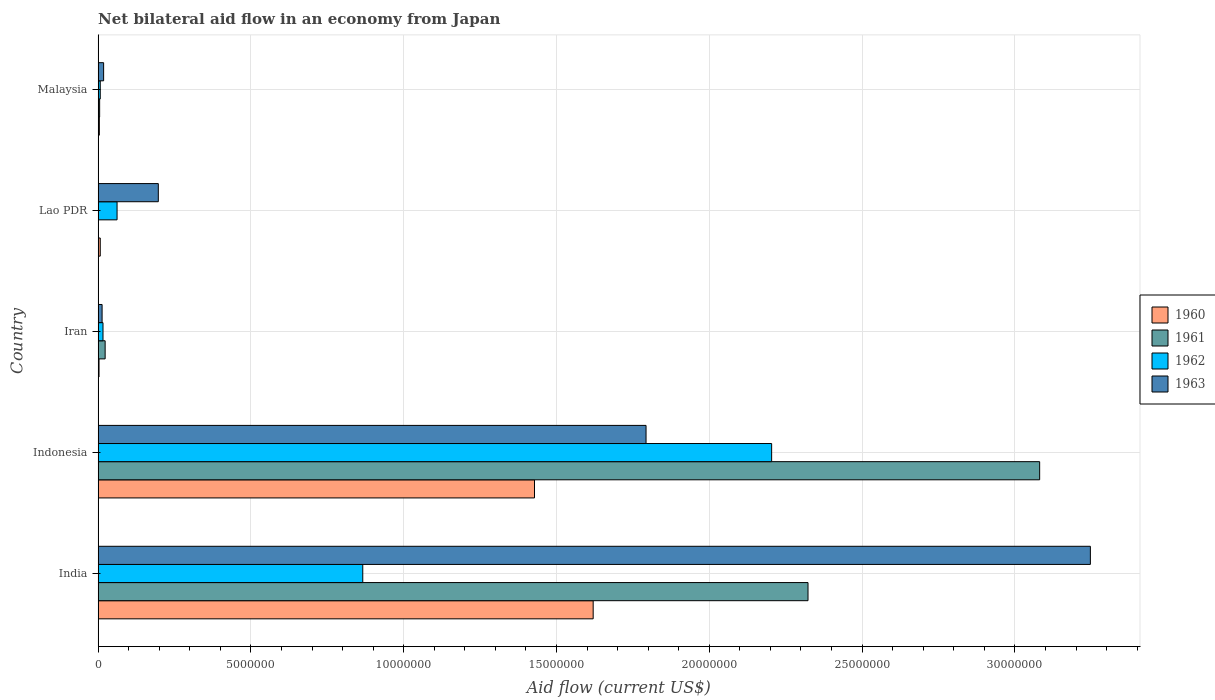Are the number of bars per tick equal to the number of legend labels?
Your answer should be very brief. Yes. How many bars are there on the 2nd tick from the top?
Your answer should be compact. 4. What is the net bilateral aid flow in 1960 in Indonesia?
Your answer should be very brief. 1.43e+07. Across all countries, what is the maximum net bilateral aid flow in 1962?
Provide a short and direct response. 2.20e+07. In which country was the net bilateral aid flow in 1962 minimum?
Keep it short and to the point. Malaysia. What is the total net bilateral aid flow in 1963 in the graph?
Your answer should be very brief. 5.27e+07. What is the difference between the net bilateral aid flow in 1961 in India and that in Iran?
Provide a succinct answer. 2.30e+07. What is the difference between the net bilateral aid flow in 1960 in Malaysia and the net bilateral aid flow in 1963 in Indonesia?
Offer a terse response. -1.79e+07. What is the average net bilateral aid flow in 1963 per country?
Make the answer very short. 1.05e+07. What is the difference between the net bilateral aid flow in 1961 and net bilateral aid flow in 1963 in Indonesia?
Offer a very short reply. 1.29e+07. What is the ratio of the net bilateral aid flow in 1962 in Indonesia to that in Iran?
Provide a short and direct response. 137.75. Is the net bilateral aid flow in 1963 in Lao PDR less than that in Malaysia?
Offer a very short reply. No. What is the difference between the highest and the second highest net bilateral aid flow in 1963?
Offer a terse response. 1.45e+07. What is the difference between the highest and the lowest net bilateral aid flow in 1960?
Your response must be concise. 1.62e+07. What does the 1st bar from the bottom in Malaysia represents?
Your answer should be very brief. 1960. Is it the case that in every country, the sum of the net bilateral aid flow in 1963 and net bilateral aid flow in 1962 is greater than the net bilateral aid flow in 1960?
Offer a terse response. Yes. Are all the bars in the graph horizontal?
Offer a very short reply. Yes. What is the difference between two consecutive major ticks on the X-axis?
Provide a succinct answer. 5.00e+06. Are the values on the major ticks of X-axis written in scientific E-notation?
Ensure brevity in your answer.  No. Does the graph contain any zero values?
Offer a terse response. No. Does the graph contain grids?
Make the answer very short. Yes. How many legend labels are there?
Your response must be concise. 4. What is the title of the graph?
Your response must be concise. Net bilateral aid flow in an economy from Japan. Does "1964" appear as one of the legend labels in the graph?
Provide a succinct answer. No. What is the label or title of the Y-axis?
Give a very brief answer. Country. What is the Aid flow (current US$) in 1960 in India?
Provide a short and direct response. 1.62e+07. What is the Aid flow (current US$) in 1961 in India?
Your answer should be very brief. 2.32e+07. What is the Aid flow (current US$) of 1962 in India?
Give a very brief answer. 8.66e+06. What is the Aid flow (current US$) of 1963 in India?
Offer a very short reply. 3.25e+07. What is the Aid flow (current US$) of 1960 in Indonesia?
Offer a terse response. 1.43e+07. What is the Aid flow (current US$) in 1961 in Indonesia?
Provide a short and direct response. 3.08e+07. What is the Aid flow (current US$) in 1962 in Indonesia?
Ensure brevity in your answer.  2.20e+07. What is the Aid flow (current US$) in 1963 in Indonesia?
Your response must be concise. 1.79e+07. What is the Aid flow (current US$) in 1960 in Iran?
Make the answer very short. 3.00e+04. What is the Aid flow (current US$) of 1961 in Iran?
Provide a succinct answer. 2.30e+05. What is the Aid flow (current US$) in 1962 in Iran?
Your answer should be very brief. 1.60e+05. What is the Aid flow (current US$) of 1961 in Lao PDR?
Offer a very short reply. 10000. What is the Aid flow (current US$) in 1962 in Lao PDR?
Make the answer very short. 6.20e+05. What is the Aid flow (current US$) of 1963 in Lao PDR?
Your response must be concise. 1.97e+06. What is the Aid flow (current US$) in 1961 in Malaysia?
Your response must be concise. 5.00e+04. Across all countries, what is the maximum Aid flow (current US$) in 1960?
Provide a succinct answer. 1.62e+07. Across all countries, what is the maximum Aid flow (current US$) of 1961?
Your answer should be very brief. 3.08e+07. Across all countries, what is the maximum Aid flow (current US$) in 1962?
Provide a succinct answer. 2.20e+07. Across all countries, what is the maximum Aid flow (current US$) of 1963?
Provide a succinct answer. 3.25e+07. Across all countries, what is the minimum Aid flow (current US$) in 1963?
Your answer should be very brief. 1.30e+05. What is the total Aid flow (current US$) of 1960 in the graph?
Give a very brief answer. 3.06e+07. What is the total Aid flow (current US$) of 1961 in the graph?
Ensure brevity in your answer.  5.43e+07. What is the total Aid flow (current US$) of 1962 in the graph?
Your response must be concise. 3.16e+07. What is the total Aid flow (current US$) in 1963 in the graph?
Make the answer very short. 5.27e+07. What is the difference between the Aid flow (current US$) of 1960 in India and that in Indonesia?
Provide a short and direct response. 1.92e+06. What is the difference between the Aid flow (current US$) of 1961 in India and that in Indonesia?
Make the answer very short. -7.58e+06. What is the difference between the Aid flow (current US$) of 1962 in India and that in Indonesia?
Offer a terse response. -1.34e+07. What is the difference between the Aid flow (current US$) in 1963 in India and that in Indonesia?
Your response must be concise. 1.45e+07. What is the difference between the Aid flow (current US$) of 1960 in India and that in Iran?
Make the answer very short. 1.62e+07. What is the difference between the Aid flow (current US$) of 1961 in India and that in Iran?
Ensure brevity in your answer.  2.30e+07. What is the difference between the Aid flow (current US$) of 1962 in India and that in Iran?
Keep it short and to the point. 8.50e+06. What is the difference between the Aid flow (current US$) in 1963 in India and that in Iran?
Give a very brief answer. 3.23e+07. What is the difference between the Aid flow (current US$) in 1960 in India and that in Lao PDR?
Provide a succinct answer. 1.61e+07. What is the difference between the Aid flow (current US$) of 1961 in India and that in Lao PDR?
Give a very brief answer. 2.32e+07. What is the difference between the Aid flow (current US$) in 1962 in India and that in Lao PDR?
Your answer should be compact. 8.04e+06. What is the difference between the Aid flow (current US$) in 1963 in India and that in Lao PDR?
Keep it short and to the point. 3.05e+07. What is the difference between the Aid flow (current US$) in 1960 in India and that in Malaysia?
Your answer should be compact. 1.62e+07. What is the difference between the Aid flow (current US$) in 1961 in India and that in Malaysia?
Provide a succinct answer. 2.32e+07. What is the difference between the Aid flow (current US$) of 1962 in India and that in Malaysia?
Keep it short and to the point. 8.59e+06. What is the difference between the Aid flow (current US$) in 1963 in India and that in Malaysia?
Your answer should be compact. 3.23e+07. What is the difference between the Aid flow (current US$) in 1960 in Indonesia and that in Iran?
Provide a short and direct response. 1.42e+07. What is the difference between the Aid flow (current US$) in 1961 in Indonesia and that in Iran?
Ensure brevity in your answer.  3.06e+07. What is the difference between the Aid flow (current US$) in 1962 in Indonesia and that in Iran?
Offer a very short reply. 2.19e+07. What is the difference between the Aid flow (current US$) of 1963 in Indonesia and that in Iran?
Keep it short and to the point. 1.78e+07. What is the difference between the Aid flow (current US$) of 1960 in Indonesia and that in Lao PDR?
Make the answer very short. 1.42e+07. What is the difference between the Aid flow (current US$) in 1961 in Indonesia and that in Lao PDR?
Keep it short and to the point. 3.08e+07. What is the difference between the Aid flow (current US$) of 1962 in Indonesia and that in Lao PDR?
Give a very brief answer. 2.14e+07. What is the difference between the Aid flow (current US$) in 1963 in Indonesia and that in Lao PDR?
Provide a succinct answer. 1.60e+07. What is the difference between the Aid flow (current US$) in 1960 in Indonesia and that in Malaysia?
Keep it short and to the point. 1.42e+07. What is the difference between the Aid flow (current US$) in 1961 in Indonesia and that in Malaysia?
Provide a succinct answer. 3.08e+07. What is the difference between the Aid flow (current US$) of 1962 in Indonesia and that in Malaysia?
Provide a succinct answer. 2.20e+07. What is the difference between the Aid flow (current US$) in 1963 in Indonesia and that in Malaysia?
Give a very brief answer. 1.78e+07. What is the difference between the Aid flow (current US$) of 1960 in Iran and that in Lao PDR?
Keep it short and to the point. -4.00e+04. What is the difference between the Aid flow (current US$) of 1962 in Iran and that in Lao PDR?
Your answer should be compact. -4.60e+05. What is the difference between the Aid flow (current US$) of 1963 in Iran and that in Lao PDR?
Your answer should be compact. -1.84e+06. What is the difference between the Aid flow (current US$) of 1961 in Iran and that in Malaysia?
Keep it short and to the point. 1.80e+05. What is the difference between the Aid flow (current US$) in 1963 in Iran and that in Malaysia?
Provide a succinct answer. -5.00e+04. What is the difference between the Aid flow (current US$) of 1961 in Lao PDR and that in Malaysia?
Your response must be concise. -4.00e+04. What is the difference between the Aid flow (current US$) of 1963 in Lao PDR and that in Malaysia?
Make the answer very short. 1.79e+06. What is the difference between the Aid flow (current US$) of 1960 in India and the Aid flow (current US$) of 1961 in Indonesia?
Your answer should be compact. -1.46e+07. What is the difference between the Aid flow (current US$) in 1960 in India and the Aid flow (current US$) in 1962 in Indonesia?
Keep it short and to the point. -5.84e+06. What is the difference between the Aid flow (current US$) in 1960 in India and the Aid flow (current US$) in 1963 in Indonesia?
Make the answer very short. -1.73e+06. What is the difference between the Aid flow (current US$) in 1961 in India and the Aid flow (current US$) in 1962 in Indonesia?
Give a very brief answer. 1.19e+06. What is the difference between the Aid flow (current US$) of 1961 in India and the Aid flow (current US$) of 1963 in Indonesia?
Your answer should be very brief. 5.30e+06. What is the difference between the Aid flow (current US$) in 1962 in India and the Aid flow (current US$) in 1963 in Indonesia?
Provide a succinct answer. -9.27e+06. What is the difference between the Aid flow (current US$) in 1960 in India and the Aid flow (current US$) in 1961 in Iran?
Provide a short and direct response. 1.60e+07. What is the difference between the Aid flow (current US$) in 1960 in India and the Aid flow (current US$) in 1962 in Iran?
Make the answer very short. 1.60e+07. What is the difference between the Aid flow (current US$) in 1960 in India and the Aid flow (current US$) in 1963 in Iran?
Your answer should be very brief. 1.61e+07. What is the difference between the Aid flow (current US$) in 1961 in India and the Aid flow (current US$) in 1962 in Iran?
Offer a terse response. 2.31e+07. What is the difference between the Aid flow (current US$) of 1961 in India and the Aid flow (current US$) of 1963 in Iran?
Offer a terse response. 2.31e+07. What is the difference between the Aid flow (current US$) of 1962 in India and the Aid flow (current US$) of 1963 in Iran?
Your answer should be compact. 8.53e+06. What is the difference between the Aid flow (current US$) of 1960 in India and the Aid flow (current US$) of 1961 in Lao PDR?
Provide a succinct answer. 1.62e+07. What is the difference between the Aid flow (current US$) of 1960 in India and the Aid flow (current US$) of 1962 in Lao PDR?
Offer a very short reply. 1.56e+07. What is the difference between the Aid flow (current US$) in 1960 in India and the Aid flow (current US$) in 1963 in Lao PDR?
Make the answer very short. 1.42e+07. What is the difference between the Aid flow (current US$) of 1961 in India and the Aid flow (current US$) of 1962 in Lao PDR?
Keep it short and to the point. 2.26e+07. What is the difference between the Aid flow (current US$) in 1961 in India and the Aid flow (current US$) in 1963 in Lao PDR?
Make the answer very short. 2.13e+07. What is the difference between the Aid flow (current US$) in 1962 in India and the Aid flow (current US$) in 1963 in Lao PDR?
Provide a short and direct response. 6.69e+06. What is the difference between the Aid flow (current US$) of 1960 in India and the Aid flow (current US$) of 1961 in Malaysia?
Your response must be concise. 1.62e+07. What is the difference between the Aid flow (current US$) in 1960 in India and the Aid flow (current US$) in 1962 in Malaysia?
Provide a short and direct response. 1.61e+07. What is the difference between the Aid flow (current US$) of 1960 in India and the Aid flow (current US$) of 1963 in Malaysia?
Your answer should be compact. 1.60e+07. What is the difference between the Aid flow (current US$) of 1961 in India and the Aid flow (current US$) of 1962 in Malaysia?
Your response must be concise. 2.32e+07. What is the difference between the Aid flow (current US$) in 1961 in India and the Aid flow (current US$) in 1963 in Malaysia?
Your answer should be compact. 2.30e+07. What is the difference between the Aid flow (current US$) of 1962 in India and the Aid flow (current US$) of 1963 in Malaysia?
Keep it short and to the point. 8.48e+06. What is the difference between the Aid flow (current US$) of 1960 in Indonesia and the Aid flow (current US$) of 1961 in Iran?
Your answer should be compact. 1.40e+07. What is the difference between the Aid flow (current US$) of 1960 in Indonesia and the Aid flow (current US$) of 1962 in Iran?
Make the answer very short. 1.41e+07. What is the difference between the Aid flow (current US$) in 1960 in Indonesia and the Aid flow (current US$) in 1963 in Iran?
Give a very brief answer. 1.42e+07. What is the difference between the Aid flow (current US$) of 1961 in Indonesia and the Aid flow (current US$) of 1962 in Iran?
Keep it short and to the point. 3.06e+07. What is the difference between the Aid flow (current US$) of 1961 in Indonesia and the Aid flow (current US$) of 1963 in Iran?
Offer a very short reply. 3.07e+07. What is the difference between the Aid flow (current US$) of 1962 in Indonesia and the Aid flow (current US$) of 1963 in Iran?
Keep it short and to the point. 2.19e+07. What is the difference between the Aid flow (current US$) in 1960 in Indonesia and the Aid flow (current US$) in 1961 in Lao PDR?
Your response must be concise. 1.43e+07. What is the difference between the Aid flow (current US$) of 1960 in Indonesia and the Aid flow (current US$) of 1962 in Lao PDR?
Your response must be concise. 1.37e+07. What is the difference between the Aid flow (current US$) of 1960 in Indonesia and the Aid flow (current US$) of 1963 in Lao PDR?
Keep it short and to the point. 1.23e+07. What is the difference between the Aid flow (current US$) of 1961 in Indonesia and the Aid flow (current US$) of 1962 in Lao PDR?
Make the answer very short. 3.02e+07. What is the difference between the Aid flow (current US$) in 1961 in Indonesia and the Aid flow (current US$) in 1963 in Lao PDR?
Your answer should be very brief. 2.88e+07. What is the difference between the Aid flow (current US$) of 1962 in Indonesia and the Aid flow (current US$) of 1963 in Lao PDR?
Give a very brief answer. 2.01e+07. What is the difference between the Aid flow (current US$) in 1960 in Indonesia and the Aid flow (current US$) in 1961 in Malaysia?
Provide a short and direct response. 1.42e+07. What is the difference between the Aid flow (current US$) in 1960 in Indonesia and the Aid flow (current US$) in 1962 in Malaysia?
Provide a short and direct response. 1.42e+07. What is the difference between the Aid flow (current US$) of 1960 in Indonesia and the Aid flow (current US$) of 1963 in Malaysia?
Give a very brief answer. 1.41e+07. What is the difference between the Aid flow (current US$) in 1961 in Indonesia and the Aid flow (current US$) in 1962 in Malaysia?
Offer a terse response. 3.07e+07. What is the difference between the Aid flow (current US$) of 1961 in Indonesia and the Aid flow (current US$) of 1963 in Malaysia?
Give a very brief answer. 3.06e+07. What is the difference between the Aid flow (current US$) of 1962 in Indonesia and the Aid flow (current US$) of 1963 in Malaysia?
Offer a very short reply. 2.19e+07. What is the difference between the Aid flow (current US$) of 1960 in Iran and the Aid flow (current US$) of 1962 in Lao PDR?
Ensure brevity in your answer.  -5.90e+05. What is the difference between the Aid flow (current US$) in 1960 in Iran and the Aid flow (current US$) in 1963 in Lao PDR?
Your response must be concise. -1.94e+06. What is the difference between the Aid flow (current US$) in 1961 in Iran and the Aid flow (current US$) in 1962 in Lao PDR?
Make the answer very short. -3.90e+05. What is the difference between the Aid flow (current US$) in 1961 in Iran and the Aid flow (current US$) in 1963 in Lao PDR?
Provide a succinct answer. -1.74e+06. What is the difference between the Aid flow (current US$) in 1962 in Iran and the Aid flow (current US$) in 1963 in Lao PDR?
Provide a short and direct response. -1.81e+06. What is the difference between the Aid flow (current US$) in 1960 in Iran and the Aid flow (current US$) in 1962 in Malaysia?
Provide a succinct answer. -4.00e+04. What is the difference between the Aid flow (current US$) of 1961 in Iran and the Aid flow (current US$) of 1963 in Malaysia?
Ensure brevity in your answer.  5.00e+04. What is the difference between the Aid flow (current US$) of 1962 in Iran and the Aid flow (current US$) of 1963 in Malaysia?
Offer a very short reply. -2.00e+04. What is the difference between the Aid flow (current US$) in 1961 in Lao PDR and the Aid flow (current US$) in 1963 in Malaysia?
Your response must be concise. -1.70e+05. What is the average Aid flow (current US$) of 1960 per country?
Provide a succinct answer. 6.12e+06. What is the average Aid flow (current US$) of 1961 per country?
Ensure brevity in your answer.  1.09e+07. What is the average Aid flow (current US$) of 1962 per country?
Ensure brevity in your answer.  6.31e+06. What is the average Aid flow (current US$) of 1963 per country?
Keep it short and to the point. 1.05e+07. What is the difference between the Aid flow (current US$) in 1960 and Aid flow (current US$) in 1961 in India?
Offer a very short reply. -7.03e+06. What is the difference between the Aid flow (current US$) in 1960 and Aid flow (current US$) in 1962 in India?
Ensure brevity in your answer.  7.54e+06. What is the difference between the Aid flow (current US$) of 1960 and Aid flow (current US$) of 1963 in India?
Provide a short and direct response. -1.63e+07. What is the difference between the Aid flow (current US$) in 1961 and Aid flow (current US$) in 1962 in India?
Ensure brevity in your answer.  1.46e+07. What is the difference between the Aid flow (current US$) of 1961 and Aid flow (current US$) of 1963 in India?
Make the answer very short. -9.24e+06. What is the difference between the Aid flow (current US$) of 1962 and Aid flow (current US$) of 1963 in India?
Ensure brevity in your answer.  -2.38e+07. What is the difference between the Aid flow (current US$) of 1960 and Aid flow (current US$) of 1961 in Indonesia?
Your answer should be compact. -1.65e+07. What is the difference between the Aid flow (current US$) of 1960 and Aid flow (current US$) of 1962 in Indonesia?
Your answer should be very brief. -7.76e+06. What is the difference between the Aid flow (current US$) in 1960 and Aid flow (current US$) in 1963 in Indonesia?
Your answer should be very brief. -3.65e+06. What is the difference between the Aid flow (current US$) of 1961 and Aid flow (current US$) of 1962 in Indonesia?
Your answer should be compact. 8.77e+06. What is the difference between the Aid flow (current US$) in 1961 and Aid flow (current US$) in 1963 in Indonesia?
Make the answer very short. 1.29e+07. What is the difference between the Aid flow (current US$) of 1962 and Aid flow (current US$) of 1963 in Indonesia?
Make the answer very short. 4.11e+06. What is the difference between the Aid flow (current US$) in 1960 and Aid flow (current US$) in 1961 in Iran?
Provide a short and direct response. -2.00e+05. What is the difference between the Aid flow (current US$) of 1960 and Aid flow (current US$) of 1962 in Iran?
Your answer should be very brief. -1.30e+05. What is the difference between the Aid flow (current US$) in 1961 and Aid flow (current US$) in 1963 in Iran?
Your response must be concise. 1.00e+05. What is the difference between the Aid flow (current US$) in 1962 and Aid flow (current US$) in 1963 in Iran?
Provide a succinct answer. 3.00e+04. What is the difference between the Aid flow (current US$) of 1960 and Aid flow (current US$) of 1961 in Lao PDR?
Offer a very short reply. 6.00e+04. What is the difference between the Aid flow (current US$) of 1960 and Aid flow (current US$) of 1962 in Lao PDR?
Ensure brevity in your answer.  -5.50e+05. What is the difference between the Aid flow (current US$) of 1960 and Aid flow (current US$) of 1963 in Lao PDR?
Ensure brevity in your answer.  -1.90e+06. What is the difference between the Aid flow (current US$) in 1961 and Aid flow (current US$) in 1962 in Lao PDR?
Give a very brief answer. -6.10e+05. What is the difference between the Aid flow (current US$) in 1961 and Aid flow (current US$) in 1963 in Lao PDR?
Ensure brevity in your answer.  -1.96e+06. What is the difference between the Aid flow (current US$) of 1962 and Aid flow (current US$) of 1963 in Lao PDR?
Your answer should be compact. -1.35e+06. What is the difference between the Aid flow (current US$) in 1960 and Aid flow (current US$) in 1962 in Malaysia?
Your answer should be compact. -3.00e+04. What is the difference between the Aid flow (current US$) of 1960 and Aid flow (current US$) of 1963 in Malaysia?
Make the answer very short. -1.40e+05. What is the difference between the Aid flow (current US$) of 1961 and Aid flow (current US$) of 1963 in Malaysia?
Make the answer very short. -1.30e+05. What is the ratio of the Aid flow (current US$) of 1960 in India to that in Indonesia?
Keep it short and to the point. 1.13. What is the ratio of the Aid flow (current US$) of 1961 in India to that in Indonesia?
Give a very brief answer. 0.75. What is the ratio of the Aid flow (current US$) of 1962 in India to that in Indonesia?
Your answer should be very brief. 0.39. What is the ratio of the Aid flow (current US$) of 1963 in India to that in Indonesia?
Give a very brief answer. 1.81. What is the ratio of the Aid flow (current US$) of 1960 in India to that in Iran?
Make the answer very short. 540. What is the ratio of the Aid flow (current US$) in 1961 in India to that in Iran?
Your answer should be compact. 101. What is the ratio of the Aid flow (current US$) of 1962 in India to that in Iran?
Your response must be concise. 54.12. What is the ratio of the Aid flow (current US$) in 1963 in India to that in Iran?
Your answer should be very brief. 249.77. What is the ratio of the Aid flow (current US$) in 1960 in India to that in Lao PDR?
Make the answer very short. 231.43. What is the ratio of the Aid flow (current US$) in 1961 in India to that in Lao PDR?
Ensure brevity in your answer.  2323. What is the ratio of the Aid flow (current US$) of 1962 in India to that in Lao PDR?
Provide a succinct answer. 13.97. What is the ratio of the Aid flow (current US$) in 1963 in India to that in Lao PDR?
Make the answer very short. 16.48. What is the ratio of the Aid flow (current US$) in 1960 in India to that in Malaysia?
Make the answer very short. 405. What is the ratio of the Aid flow (current US$) of 1961 in India to that in Malaysia?
Give a very brief answer. 464.6. What is the ratio of the Aid flow (current US$) in 1962 in India to that in Malaysia?
Your answer should be compact. 123.71. What is the ratio of the Aid flow (current US$) in 1963 in India to that in Malaysia?
Offer a very short reply. 180.39. What is the ratio of the Aid flow (current US$) in 1960 in Indonesia to that in Iran?
Offer a terse response. 476. What is the ratio of the Aid flow (current US$) in 1961 in Indonesia to that in Iran?
Your answer should be compact. 133.96. What is the ratio of the Aid flow (current US$) of 1962 in Indonesia to that in Iran?
Your answer should be compact. 137.75. What is the ratio of the Aid flow (current US$) of 1963 in Indonesia to that in Iran?
Offer a very short reply. 137.92. What is the ratio of the Aid flow (current US$) of 1960 in Indonesia to that in Lao PDR?
Your response must be concise. 204. What is the ratio of the Aid flow (current US$) in 1961 in Indonesia to that in Lao PDR?
Give a very brief answer. 3081. What is the ratio of the Aid flow (current US$) of 1962 in Indonesia to that in Lao PDR?
Your answer should be very brief. 35.55. What is the ratio of the Aid flow (current US$) of 1963 in Indonesia to that in Lao PDR?
Your response must be concise. 9.1. What is the ratio of the Aid flow (current US$) of 1960 in Indonesia to that in Malaysia?
Keep it short and to the point. 357. What is the ratio of the Aid flow (current US$) in 1961 in Indonesia to that in Malaysia?
Offer a very short reply. 616.2. What is the ratio of the Aid flow (current US$) of 1962 in Indonesia to that in Malaysia?
Offer a terse response. 314.86. What is the ratio of the Aid flow (current US$) in 1963 in Indonesia to that in Malaysia?
Make the answer very short. 99.61. What is the ratio of the Aid flow (current US$) in 1960 in Iran to that in Lao PDR?
Your response must be concise. 0.43. What is the ratio of the Aid flow (current US$) of 1962 in Iran to that in Lao PDR?
Your answer should be compact. 0.26. What is the ratio of the Aid flow (current US$) of 1963 in Iran to that in Lao PDR?
Provide a short and direct response. 0.07. What is the ratio of the Aid flow (current US$) of 1960 in Iran to that in Malaysia?
Offer a very short reply. 0.75. What is the ratio of the Aid flow (current US$) of 1962 in Iran to that in Malaysia?
Your response must be concise. 2.29. What is the ratio of the Aid flow (current US$) in 1963 in Iran to that in Malaysia?
Ensure brevity in your answer.  0.72. What is the ratio of the Aid flow (current US$) of 1962 in Lao PDR to that in Malaysia?
Your answer should be very brief. 8.86. What is the ratio of the Aid flow (current US$) in 1963 in Lao PDR to that in Malaysia?
Give a very brief answer. 10.94. What is the difference between the highest and the second highest Aid flow (current US$) of 1960?
Offer a terse response. 1.92e+06. What is the difference between the highest and the second highest Aid flow (current US$) of 1961?
Your response must be concise. 7.58e+06. What is the difference between the highest and the second highest Aid flow (current US$) of 1962?
Your answer should be very brief. 1.34e+07. What is the difference between the highest and the second highest Aid flow (current US$) of 1963?
Keep it short and to the point. 1.45e+07. What is the difference between the highest and the lowest Aid flow (current US$) of 1960?
Your answer should be very brief. 1.62e+07. What is the difference between the highest and the lowest Aid flow (current US$) of 1961?
Your answer should be compact. 3.08e+07. What is the difference between the highest and the lowest Aid flow (current US$) of 1962?
Your answer should be very brief. 2.20e+07. What is the difference between the highest and the lowest Aid flow (current US$) of 1963?
Offer a very short reply. 3.23e+07. 